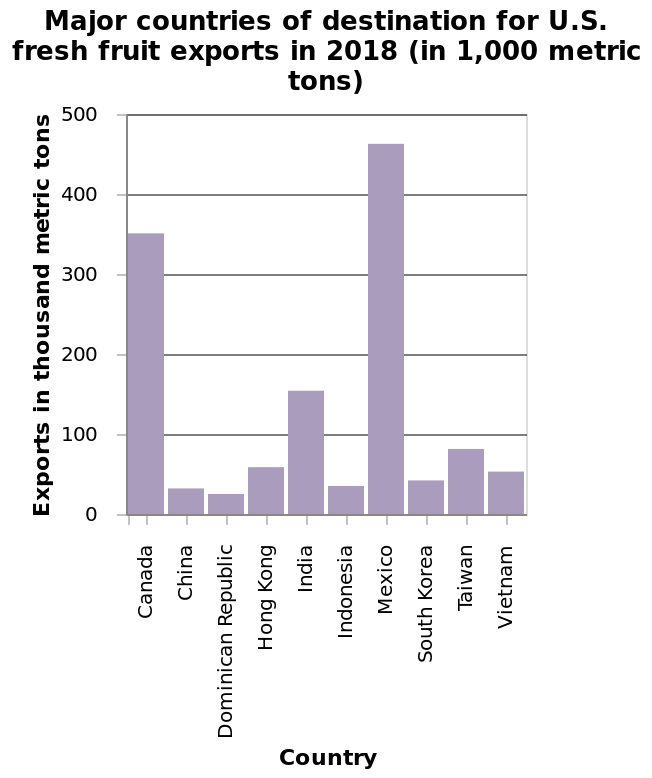<image>
Which nearby countries does the USA export most of its fruit to?  The USA exports most of its fruit to Canada and Mexico. What is the title of the bar diagram? The bar diagram is titled "Major countries of destination for U.S. fresh fruit exports in 2018 (in 1,000 metric tons)." please summary the statistics and relations of the chart The USA exports more fruit to Mexico than it does any other country. The least amount of fruit goes to the Dominican Republic. It exports most of its fruit to nearby countries Canada and Mexico. Most of the countries the US exports fresh fruit to are in Asia. 